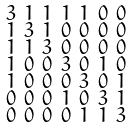Convert formula to latex. <formula><loc_0><loc_0><loc_500><loc_500>\begin{smallmatrix} 3 & 1 & 1 & 1 & 1 & 0 & 0 \\ 1 & 3 & 1 & 0 & 0 & 0 & 0 \\ 1 & 1 & 3 & 0 & 0 & 0 & 0 \\ 1 & 0 & 0 & 3 & 0 & 1 & 0 \\ 1 & 0 & 0 & 0 & 3 & 0 & 1 \\ 0 & 0 & 0 & 1 & 0 & 3 & 1 \\ 0 & 0 & 0 & 0 & 1 & 1 & 3 \end{smallmatrix}</formula> 